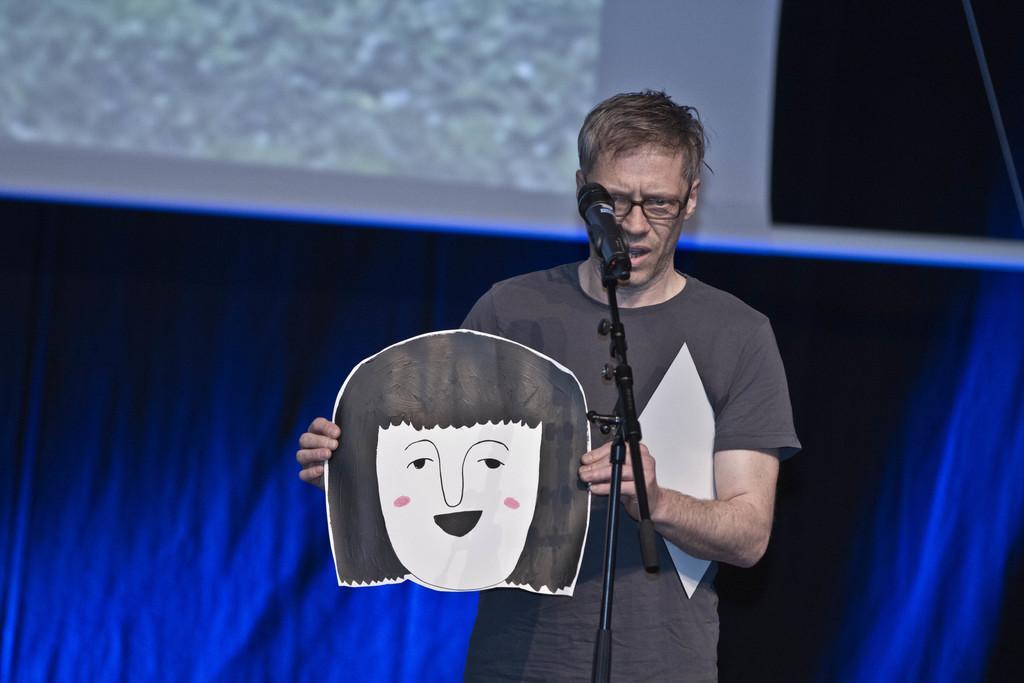How would you summarize this image in a sentence or two? In this image we can see a person and the person is holding a paper. In front of the person we can see a mic with a stand. Behind the person we can see a blue background. At the top we can see some image displayed on the projector screen. 